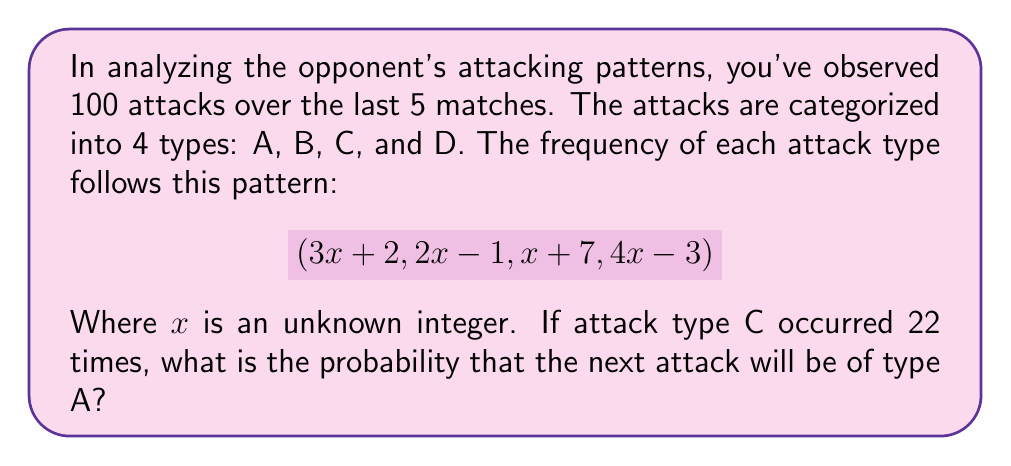Help me with this question. 1) Given that attack type C occurred 22 times, we can set up the equation:
   $$x + 7 = 22$$
   $$x = 15$$

2) Now we can calculate the frequency of each attack type:
   Type A: $3x + 2 = 3(15) + 2 = 47$
   Type B: $2x - 1 = 2(15) - 1 = 29$
   Type C: $x + 7 = 15 + 7 = 22$ (as given)
   Type D: $4x - 3 = 4(15) - 3 = 57$

3) To verify, let's sum up all attacks:
   $$47 + 29 + 22 + 57 = 155$$ (total number of attacks)

4) The probability of the next attack being type A is the frequency of A divided by the total number of attacks:

   $$P(A) = \frac{47}{155}$$

5) This fraction can be reduced by dividing both numerator and denominator by their greatest common divisor (GCD), which is 1.
Answer: $\frac{47}{155}$ 